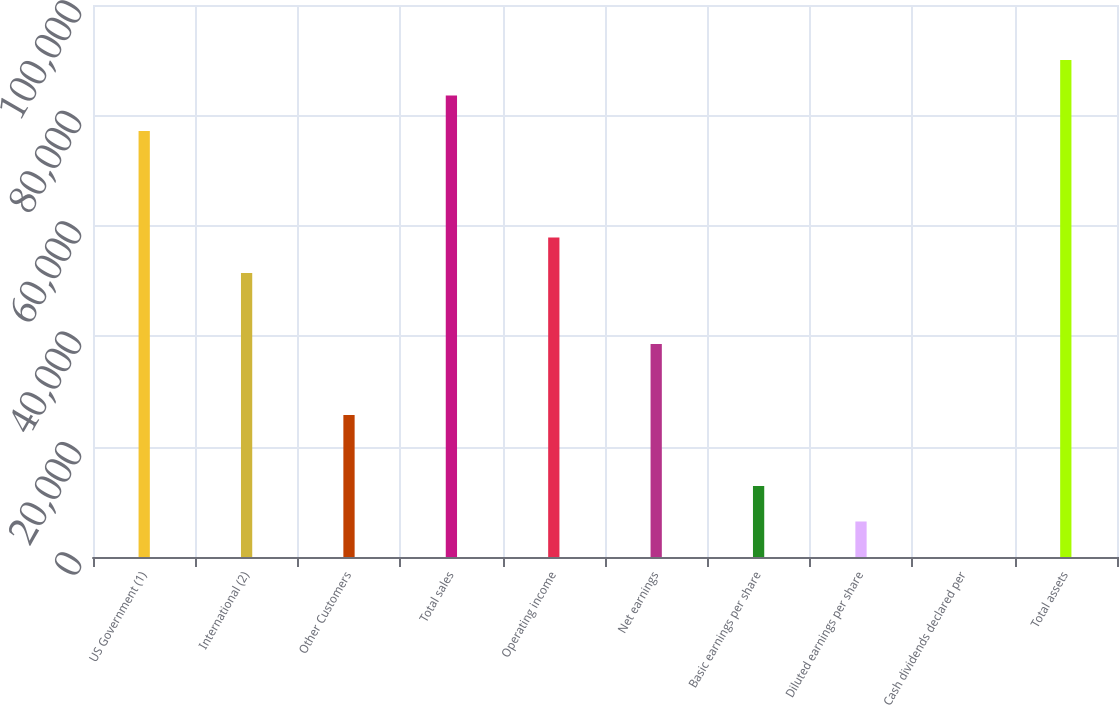Convert chart. <chart><loc_0><loc_0><loc_500><loc_500><bar_chart><fcel>US Government (1)<fcel>International (2)<fcel>Other Customers<fcel>Total sales<fcel>Operating income<fcel>Net earnings<fcel>Basic earnings per share<fcel>Diluted earnings per share<fcel>Cash dividends declared per<fcel>Total assets<nl><fcel>77159.5<fcel>51440.6<fcel>25721.6<fcel>83589.2<fcel>57870.3<fcel>38581.1<fcel>12862.2<fcel>6432.44<fcel>2.71<fcel>90018.9<nl></chart> 